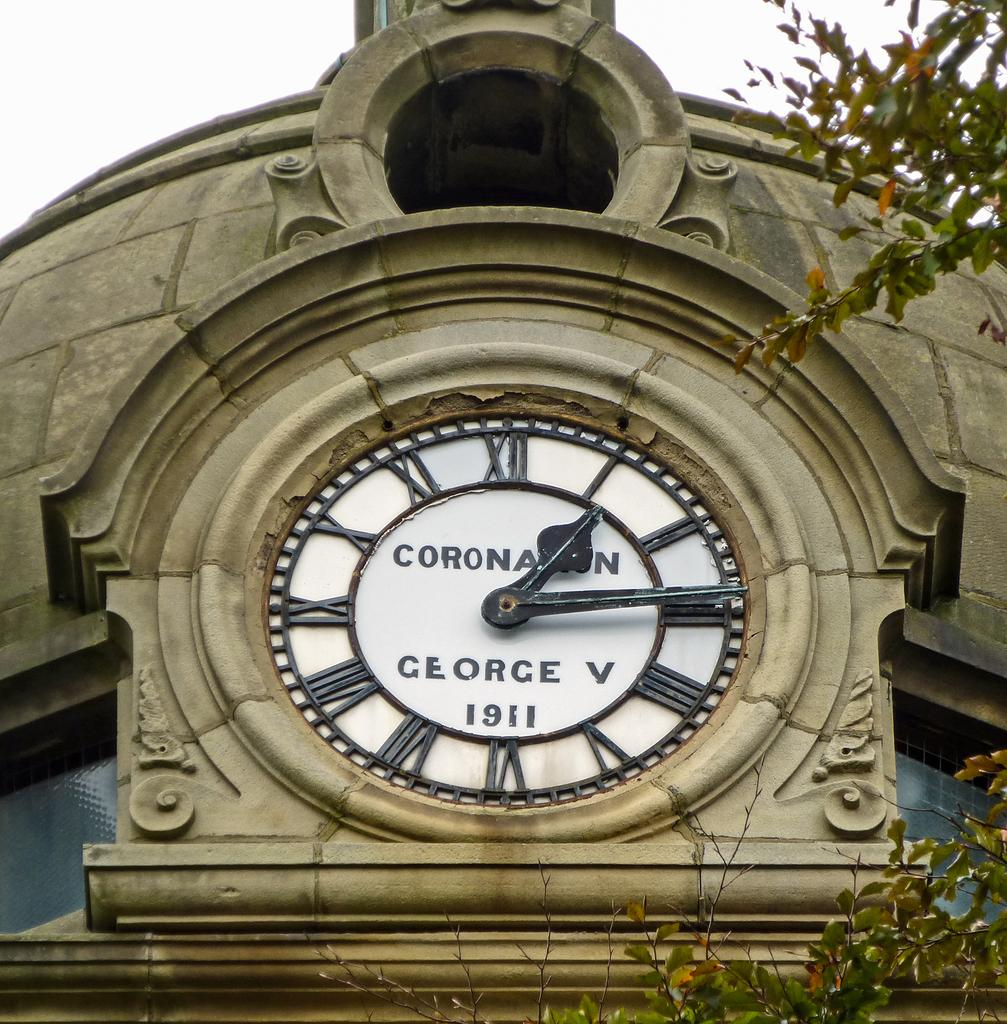<image>
Render a clear and concise summary of the photo. A large clock commemorating the coronation of George V in 1911 with roman numerals for the numbers is built into a large building. 